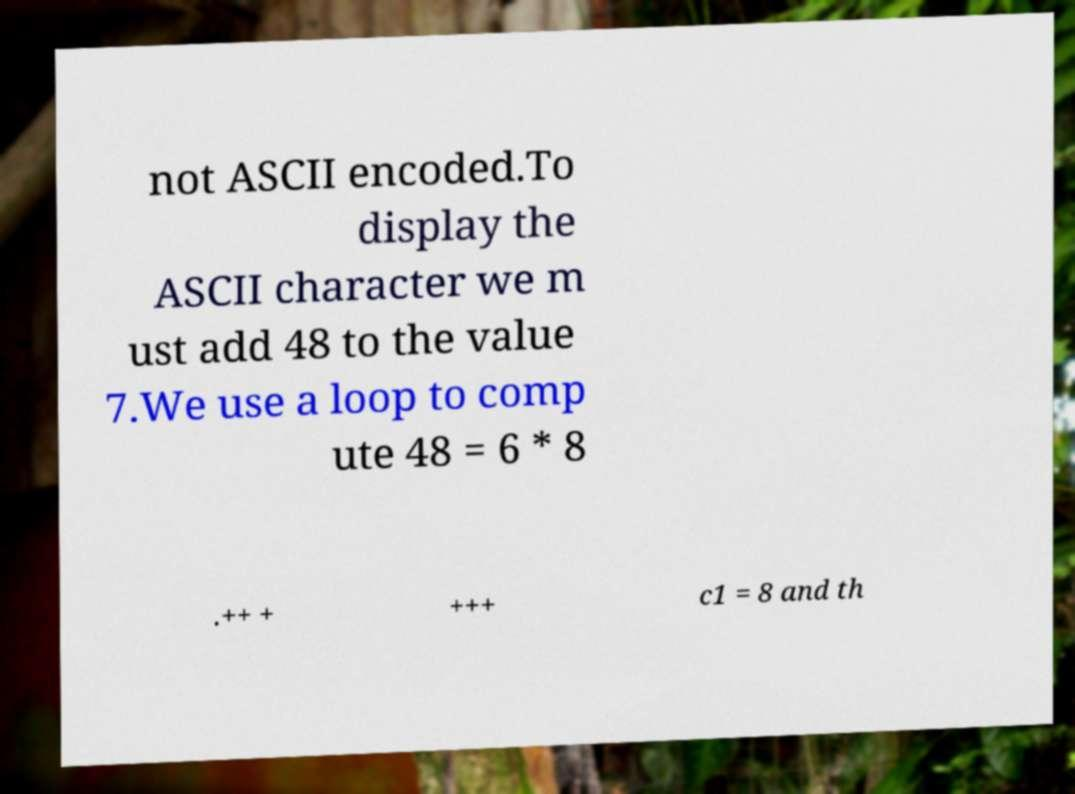Please read and relay the text visible in this image. What does it say? not ASCII encoded.To display the ASCII character we m ust add 48 to the value 7.We use a loop to comp ute 48 = 6 * 8 .++ + +++ c1 = 8 and th 